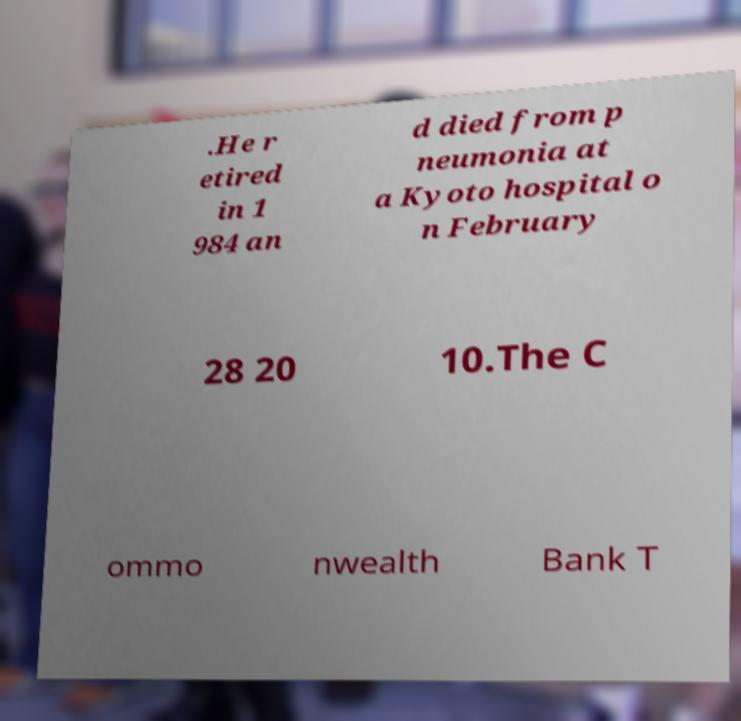What messages or text are displayed in this image? I need them in a readable, typed format. .He r etired in 1 984 an d died from p neumonia at a Kyoto hospital o n February 28 20 10.The C ommo nwealth Bank T 